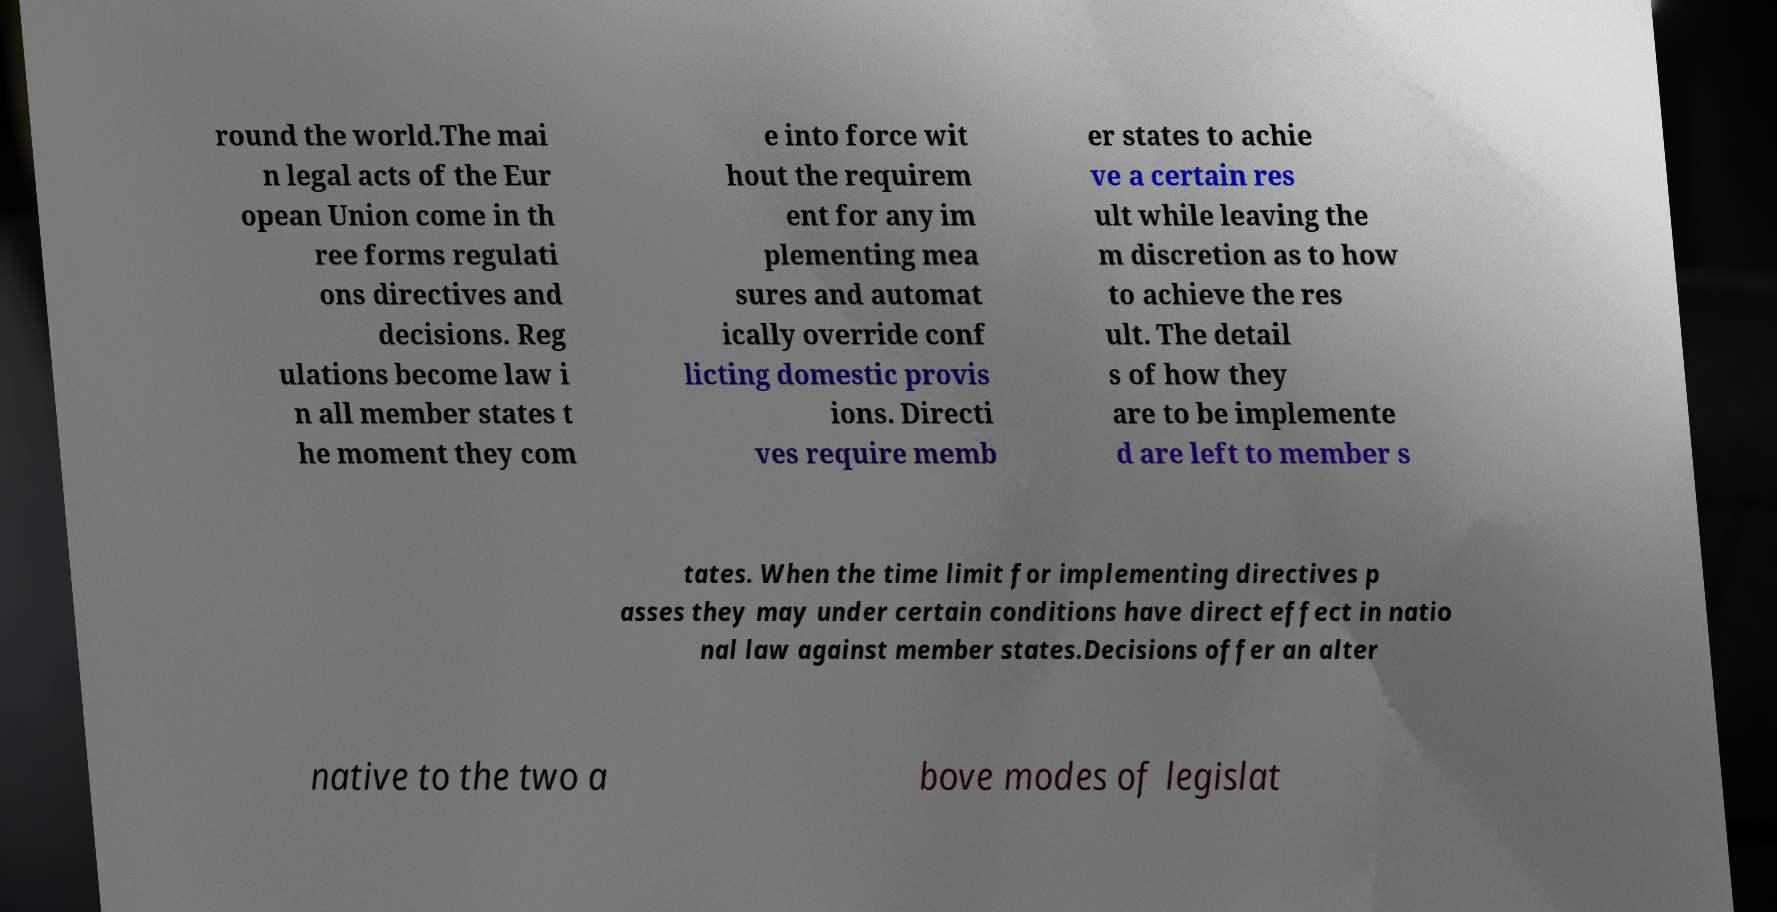Can you accurately transcribe the text from the provided image for me? round the world.The mai n legal acts of the Eur opean Union come in th ree forms regulati ons directives and decisions. Reg ulations become law i n all member states t he moment they com e into force wit hout the requirem ent for any im plementing mea sures and automat ically override conf licting domestic provis ions. Directi ves require memb er states to achie ve a certain res ult while leaving the m discretion as to how to achieve the res ult. The detail s of how they are to be implemente d are left to member s tates. When the time limit for implementing directives p asses they may under certain conditions have direct effect in natio nal law against member states.Decisions offer an alter native to the two a bove modes of legislat 